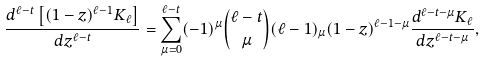<formula> <loc_0><loc_0><loc_500><loc_500>\frac { d ^ { \ell - t } \left [ ( 1 - z ) ^ { \ell - 1 } K _ { \ell } \right ] } { d z ^ { \ell - t } } = \sum _ { \mu = 0 } ^ { \ell - t } ( - 1 ) ^ { \mu } \binom { \ell - t } { \mu } ( \ell - 1 ) _ { \mu } ( 1 - z ) ^ { \ell - 1 - \mu } \frac { d ^ { \ell - t - \mu } K _ { \ell } } { d z ^ { \ell - t - \mu } } ,</formula> 